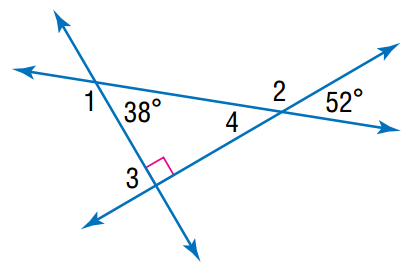Answer the mathemtical geometry problem and directly provide the correct option letter.
Question: Find the angle measure of \angle 4.
Choices: A: 38 B: 42 C: 52 D: 62 C 